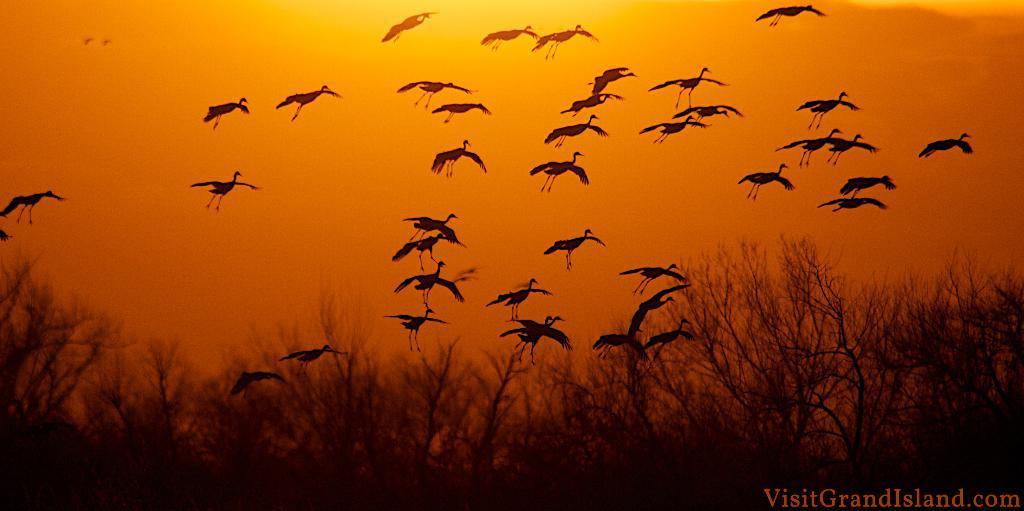In one or two sentences, can you explain what this image depicts? In this image I see the birds and I see number of plants and I see the sky and I see the watermark over here and I see that the sky is of yellow and orange in color. 